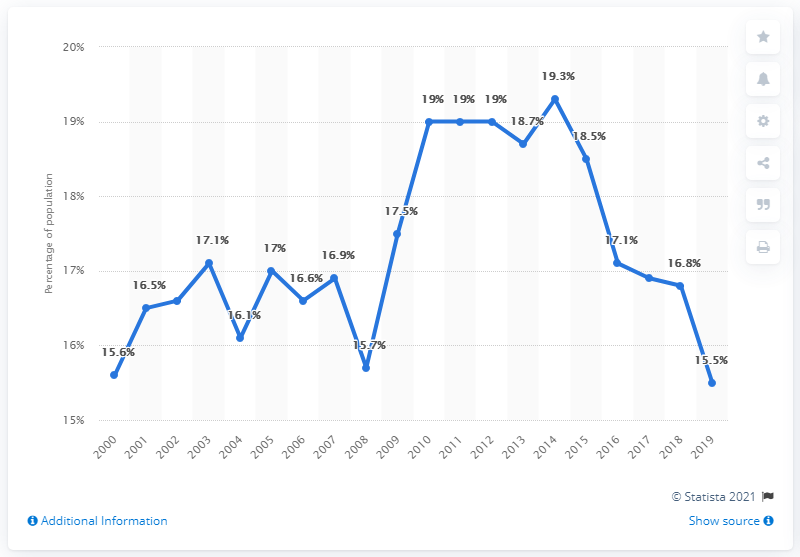Draw attention to some important aspects in this diagram. The poverty rate in the United States varies from the lowest to the highest, with the highest poverty rate being 3.8 times higher than the lowest poverty rate. In 2014, the poverty rate was the highest among the given years. 